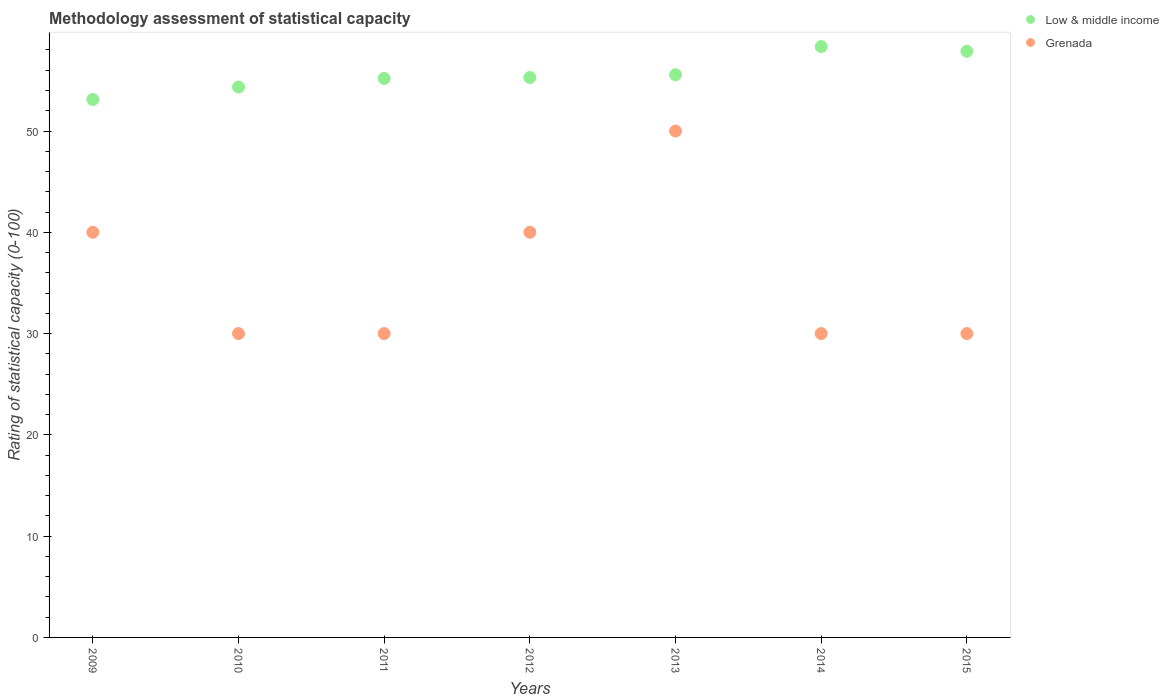How many different coloured dotlines are there?
Your response must be concise. 2. Is the number of dotlines equal to the number of legend labels?
Ensure brevity in your answer.  Yes. Across all years, what is the maximum rating of statistical capacity in Low & middle income?
Your answer should be very brief. 58.33. Across all years, what is the minimum rating of statistical capacity in Grenada?
Your answer should be very brief. 30. In which year was the rating of statistical capacity in Low & middle income maximum?
Ensure brevity in your answer.  2014. In which year was the rating of statistical capacity in Grenada minimum?
Give a very brief answer. 2010. What is the total rating of statistical capacity in Low & middle income in the graph?
Ensure brevity in your answer.  389.68. What is the difference between the rating of statistical capacity in Low & middle income in 2012 and that in 2015?
Offer a terse response. -2.59. What is the difference between the rating of statistical capacity in Low & middle income in 2011 and the rating of statistical capacity in Grenada in 2009?
Your response must be concise. 15.19. What is the average rating of statistical capacity in Low & middle income per year?
Keep it short and to the point. 55.67. In the year 2009, what is the difference between the rating of statistical capacity in Grenada and rating of statistical capacity in Low & middle income?
Your response must be concise. -13.11. What is the ratio of the rating of statistical capacity in Low & middle income in 2010 to that in 2012?
Provide a short and direct response. 0.98. Is the difference between the rating of statistical capacity in Grenada in 2012 and 2013 greater than the difference between the rating of statistical capacity in Low & middle income in 2012 and 2013?
Your response must be concise. No. What is the difference between the highest and the second highest rating of statistical capacity in Low & middle income?
Offer a very short reply. 0.46. What is the difference between the highest and the lowest rating of statistical capacity in Low & middle income?
Offer a terse response. 5.22. Does the rating of statistical capacity in Low & middle income monotonically increase over the years?
Your answer should be very brief. No. Is the rating of statistical capacity in Low & middle income strictly greater than the rating of statistical capacity in Grenada over the years?
Give a very brief answer. Yes. Is the rating of statistical capacity in Grenada strictly less than the rating of statistical capacity in Low & middle income over the years?
Provide a short and direct response. Yes. Are the values on the major ticks of Y-axis written in scientific E-notation?
Your response must be concise. No. Does the graph contain any zero values?
Your answer should be very brief. No. Where does the legend appear in the graph?
Provide a succinct answer. Top right. How many legend labels are there?
Make the answer very short. 2. How are the legend labels stacked?
Give a very brief answer. Vertical. What is the title of the graph?
Offer a very short reply. Methodology assessment of statistical capacity. What is the label or title of the X-axis?
Offer a terse response. Years. What is the label or title of the Y-axis?
Keep it short and to the point. Rating of statistical capacity (0-100). What is the Rating of statistical capacity (0-100) of Low & middle income in 2009?
Your answer should be very brief. 53.11. What is the Rating of statistical capacity (0-100) in Low & middle income in 2010?
Your answer should be very brief. 54.34. What is the Rating of statistical capacity (0-100) in Grenada in 2010?
Offer a very short reply. 30. What is the Rating of statistical capacity (0-100) of Low & middle income in 2011?
Offer a terse response. 55.19. What is the Rating of statistical capacity (0-100) of Grenada in 2011?
Make the answer very short. 30. What is the Rating of statistical capacity (0-100) in Low & middle income in 2012?
Keep it short and to the point. 55.28. What is the Rating of statistical capacity (0-100) in Grenada in 2012?
Ensure brevity in your answer.  40. What is the Rating of statistical capacity (0-100) in Low & middle income in 2013?
Give a very brief answer. 55.56. What is the Rating of statistical capacity (0-100) of Low & middle income in 2014?
Provide a short and direct response. 58.33. What is the Rating of statistical capacity (0-100) of Grenada in 2014?
Your answer should be compact. 30. What is the Rating of statistical capacity (0-100) in Low & middle income in 2015?
Your answer should be compact. 57.87. Across all years, what is the maximum Rating of statistical capacity (0-100) in Low & middle income?
Make the answer very short. 58.33. Across all years, what is the minimum Rating of statistical capacity (0-100) in Low & middle income?
Ensure brevity in your answer.  53.11. What is the total Rating of statistical capacity (0-100) of Low & middle income in the graph?
Offer a very short reply. 389.68. What is the total Rating of statistical capacity (0-100) in Grenada in the graph?
Give a very brief answer. 250. What is the difference between the Rating of statistical capacity (0-100) in Low & middle income in 2009 and that in 2010?
Keep it short and to the point. -1.23. What is the difference between the Rating of statistical capacity (0-100) of Grenada in 2009 and that in 2010?
Make the answer very short. 10. What is the difference between the Rating of statistical capacity (0-100) in Low & middle income in 2009 and that in 2011?
Offer a terse response. -2.08. What is the difference between the Rating of statistical capacity (0-100) of Grenada in 2009 and that in 2011?
Offer a very short reply. 10. What is the difference between the Rating of statistical capacity (0-100) in Low & middle income in 2009 and that in 2012?
Make the answer very short. -2.17. What is the difference between the Rating of statistical capacity (0-100) in Low & middle income in 2009 and that in 2013?
Offer a terse response. -2.44. What is the difference between the Rating of statistical capacity (0-100) of Low & middle income in 2009 and that in 2014?
Give a very brief answer. -5.22. What is the difference between the Rating of statistical capacity (0-100) in Low & middle income in 2009 and that in 2015?
Your response must be concise. -4.76. What is the difference between the Rating of statistical capacity (0-100) of Low & middle income in 2010 and that in 2011?
Give a very brief answer. -0.85. What is the difference between the Rating of statistical capacity (0-100) of Low & middle income in 2010 and that in 2012?
Your answer should be very brief. -0.94. What is the difference between the Rating of statistical capacity (0-100) of Grenada in 2010 and that in 2012?
Provide a succinct answer. -10. What is the difference between the Rating of statistical capacity (0-100) in Low & middle income in 2010 and that in 2013?
Your answer should be very brief. -1.22. What is the difference between the Rating of statistical capacity (0-100) in Low & middle income in 2010 and that in 2014?
Offer a very short reply. -3.99. What is the difference between the Rating of statistical capacity (0-100) in Grenada in 2010 and that in 2014?
Give a very brief answer. 0. What is the difference between the Rating of statistical capacity (0-100) in Low & middle income in 2010 and that in 2015?
Ensure brevity in your answer.  -3.53. What is the difference between the Rating of statistical capacity (0-100) of Grenada in 2010 and that in 2015?
Make the answer very short. 0. What is the difference between the Rating of statistical capacity (0-100) in Low & middle income in 2011 and that in 2012?
Provide a short and direct response. -0.09. What is the difference between the Rating of statistical capacity (0-100) of Grenada in 2011 and that in 2012?
Give a very brief answer. -10. What is the difference between the Rating of statistical capacity (0-100) of Low & middle income in 2011 and that in 2013?
Your answer should be compact. -0.37. What is the difference between the Rating of statistical capacity (0-100) of Low & middle income in 2011 and that in 2014?
Give a very brief answer. -3.14. What is the difference between the Rating of statistical capacity (0-100) in Grenada in 2011 and that in 2014?
Keep it short and to the point. 0. What is the difference between the Rating of statistical capacity (0-100) in Low & middle income in 2011 and that in 2015?
Offer a terse response. -2.68. What is the difference between the Rating of statistical capacity (0-100) of Grenada in 2011 and that in 2015?
Your answer should be compact. 0. What is the difference between the Rating of statistical capacity (0-100) of Low & middle income in 2012 and that in 2013?
Your response must be concise. -0.27. What is the difference between the Rating of statistical capacity (0-100) in Low & middle income in 2012 and that in 2014?
Offer a very short reply. -3.05. What is the difference between the Rating of statistical capacity (0-100) of Low & middle income in 2012 and that in 2015?
Offer a very short reply. -2.59. What is the difference between the Rating of statistical capacity (0-100) in Grenada in 2012 and that in 2015?
Make the answer very short. 10. What is the difference between the Rating of statistical capacity (0-100) of Low & middle income in 2013 and that in 2014?
Offer a very short reply. -2.78. What is the difference between the Rating of statistical capacity (0-100) of Low & middle income in 2013 and that in 2015?
Provide a short and direct response. -2.31. What is the difference between the Rating of statistical capacity (0-100) of Grenada in 2013 and that in 2015?
Ensure brevity in your answer.  20. What is the difference between the Rating of statistical capacity (0-100) in Low & middle income in 2014 and that in 2015?
Your answer should be compact. 0.46. What is the difference between the Rating of statistical capacity (0-100) in Grenada in 2014 and that in 2015?
Your answer should be very brief. 0. What is the difference between the Rating of statistical capacity (0-100) of Low & middle income in 2009 and the Rating of statistical capacity (0-100) of Grenada in 2010?
Your response must be concise. 23.11. What is the difference between the Rating of statistical capacity (0-100) in Low & middle income in 2009 and the Rating of statistical capacity (0-100) in Grenada in 2011?
Provide a short and direct response. 23.11. What is the difference between the Rating of statistical capacity (0-100) of Low & middle income in 2009 and the Rating of statistical capacity (0-100) of Grenada in 2012?
Provide a short and direct response. 13.11. What is the difference between the Rating of statistical capacity (0-100) of Low & middle income in 2009 and the Rating of statistical capacity (0-100) of Grenada in 2013?
Offer a very short reply. 3.11. What is the difference between the Rating of statistical capacity (0-100) of Low & middle income in 2009 and the Rating of statistical capacity (0-100) of Grenada in 2014?
Offer a very short reply. 23.11. What is the difference between the Rating of statistical capacity (0-100) of Low & middle income in 2009 and the Rating of statistical capacity (0-100) of Grenada in 2015?
Your answer should be compact. 23.11. What is the difference between the Rating of statistical capacity (0-100) of Low & middle income in 2010 and the Rating of statistical capacity (0-100) of Grenada in 2011?
Your answer should be compact. 24.34. What is the difference between the Rating of statistical capacity (0-100) of Low & middle income in 2010 and the Rating of statistical capacity (0-100) of Grenada in 2012?
Your answer should be compact. 14.34. What is the difference between the Rating of statistical capacity (0-100) of Low & middle income in 2010 and the Rating of statistical capacity (0-100) of Grenada in 2013?
Your answer should be very brief. 4.34. What is the difference between the Rating of statistical capacity (0-100) of Low & middle income in 2010 and the Rating of statistical capacity (0-100) of Grenada in 2014?
Your answer should be compact. 24.34. What is the difference between the Rating of statistical capacity (0-100) in Low & middle income in 2010 and the Rating of statistical capacity (0-100) in Grenada in 2015?
Keep it short and to the point. 24.34. What is the difference between the Rating of statistical capacity (0-100) in Low & middle income in 2011 and the Rating of statistical capacity (0-100) in Grenada in 2012?
Make the answer very short. 15.19. What is the difference between the Rating of statistical capacity (0-100) of Low & middle income in 2011 and the Rating of statistical capacity (0-100) of Grenada in 2013?
Provide a short and direct response. 5.19. What is the difference between the Rating of statistical capacity (0-100) of Low & middle income in 2011 and the Rating of statistical capacity (0-100) of Grenada in 2014?
Provide a short and direct response. 25.19. What is the difference between the Rating of statistical capacity (0-100) of Low & middle income in 2011 and the Rating of statistical capacity (0-100) of Grenada in 2015?
Ensure brevity in your answer.  25.19. What is the difference between the Rating of statistical capacity (0-100) of Low & middle income in 2012 and the Rating of statistical capacity (0-100) of Grenada in 2013?
Give a very brief answer. 5.28. What is the difference between the Rating of statistical capacity (0-100) of Low & middle income in 2012 and the Rating of statistical capacity (0-100) of Grenada in 2014?
Your answer should be very brief. 25.28. What is the difference between the Rating of statistical capacity (0-100) in Low & middle income in 2012 and the Rating of statistical capacity (0-100) in Grenada in 2015?
Offer a very short reply. 25.28. What is the difference between the Rating of statistical capacity (0-100) in Low & middle income in 2013 and the Rating of statistical capacity (0-100) in Grenada in 2014?
Offer a terse response. 25.56. What is the difference between the Rating of statistical capacity (0-100) in Low & middle income in 2013 and the Rating of statistical capacity (0-100) in Grenada in 2015?
Give a very brief answer. 25.56. What is the difference between the Rating of statistical capacity (0-100) in Low & middle income in 2014 and the Rating of statistical capacity (0-100) in Grenada in 2015?
Give a very brief answer. 28.33. What is the average Rating of statistical capacity (0-100) in Low & middle income per year?
Your answer should be compact. 55.67. What is the average Rating of statistical capacity (0-100) of Grenada per year?
Provide a short and direct response. 35.71. In the year 2009, what is the difference between the Rating of statistical capacity (0-100) of Low & middle income and Rating of statistical capacity (0-100) of Grenada?
Offer a very short reply. 13.11. In the year 2010, what is the difference between the Rating of statistical capacity (0-100) in Low & middle income and Rating of statistical capacity (0-100) in Grenada?
Make the answer very short. 24.34. In the year 2011, what is the difference between the Rating of statistical capacity (0-100) of Low & middle income and Rating of statistical capacity (0-100) of Grenada?
Your answer should be compact. 25.19. In the year 2012, what is the difference between the Rating of statistical capacity (0-100) in Low & middle income and Rating of statistical capacity (0-100) in Grenada?
Give a very brief answer. 15.28. In the year 2013, what is the difference between the Rating of statistical capacity (0-100) in Low & middle income and Rating of statistical capacity (0-100) in Grenada?
Ensure brevity in your answer.  5.56. In the year 2014, what is the difference between the Rating of statistical capacity (0-100) in Low & middle income and Rating of statistical capacity (0-100) in Grenada?
Your answer should be very brief. 28.33. In the year 2015, what is the difference between the Rating of statistical capacity (0-100) in Low & middle income and Rating of statistical capacity (0-100) in Grenada?
Ensure brevity in your answer.  27.87. What is the ratio of the Rating of statistical capacity (0-100) of Low & middle income in 2009 to that in 2010?
Your answer should be very brief. 0.98. What is the ratio of the Rating of statistical capacity (0-100) in Low & middle income in 2009 to that in 2011?
Your answer should be compact. 0.96. What is the ratio of the Rating of statistical capacity (0-100) of Grenada in 2009 to that in 2011?
Your response must be concise. 1.33. What is the ratio of the Rating of statistical capacity (0-100) of Low & middle income in 2009 to that in 2012?
Your answer should be very brief. 0.96. What is the ratio of the Rating of statistical capacity (0-100) in Grenada in 2009 to that in 2012?
Your response must be concise. 1. What is the ratio of the Rating of statistical capacity (0-100) of Low & middle income in 2009 to that in 2013?
Provide a short and direct response. 0.96. What is the ratio of the Rating of statistical capacity (0-100) of Grenada in 2009 to that in 2013?
Ensure brevity in your answer.  0.8. What is the ratio of the Rating of statistical capacity (0-100) of Low & middle income in 2009 to that in 2014?
Provide a short and direct response. 0.91. What is the ratio of the Rating of statistical capacity (0-100) of Grenada in 2009 to that in 2014?
Provide a succinct answer. 1.33. What is the ratio of the Rating of statistical capacity (0-100) of Low & middle income in 2009 to that in 2015?
Give a very brief answer. 0.92. What is the ratio of the Rating of statistical capacity (0-100) of Grenada in 2009 to that in 2015?
Offer a very short reply. 1.33. What is the ratio of the Rating of statistical capacity (0-100) of Low & middle income in 2010 to that in 2011?
Your answer should be compact. 0.98. What is the ratio of the Rating of statistical capacity (0-100) in Grenada in 2010 to that in 2011?
Provide a succinct answer. 1. What is the ratio of the Rating of statistical capacity (0-100) in Low & middle income in 2010 to that in 2012?
Provide a short and direct response. 0.98. What is the ratio of the Rating of statistical capacity (0-100) in Grenada in 2010 to that in 2012?
Give a very brief answer. 0.75. What is the ratio of the Rating of statistical capacity (0-100) in Low & middle income in 2010 to that in 2013?
Make the answer very short. 0.98. What is the ratio of the Rating of statistical capacity (0-100) of Low & middle income in 2010 to that in 2014?
Keep it short and to the point. 0.93. What is the ratio of the Rating of statistical capacity (0-100) in Grenada in 2010 to that in 2014?
Provide a succinct answer. 1. What is the ratio of the Rating of statistical capacity (0-100) in Low & middle income in 2010 to that in 2015?
Give a very brief answer. 0.94. What is the ratio of the Rating of statistical capacity (0-100) of Grenada in 2010 to that in 2015?
Your answer should be compact. 1. What is the ratio of the Rating of statistical capacity (0-100) in Low & middle income in 2011 to that in 2014?
Offer a terse response. 0.95. What is the ratio of the Rating of statistical capacity (0-100) of Low & middle income in 2011 to that in 2015?
Offer a very short reply. 0.95. What is the ratio of the Rating of statistical capacity (0-100) in Low & middle income in 2012 to that in 2013?
Give a very brief answer. 1. What is the ratio of the Rating of statistical capacity (0-100) in Low & middle income in 2012 to that in 2014?
Offer a very short reply. 0.95. What is the ratio of the Rating of statistical capacity (0-100) of Grenada in 2012 to that in 2014?
Your answer should be compact. 1.33. What is the ratio of the Rating of statistical capacity (0-100) in Low & middle income in 2012 to that in 2015?
Your answer should be compact. 0.96. What is the ratio of the Rating of statistical capacity (0-100) of Low & middle income in 2013 to that in 2014?
Offer a very short reply. 0.95. What is the ratio of the Rating of statistical capacity (0-100) of Grenada in 2013 to that in 2014?
Make the answer very short. 1.67. What is the ratio of the Rating of statistical capacity (0-100) in Low & middle income in 2013 to that in 2015?
Your answer should be compact. 0.96. What is the difference between the highest and the second highest Rating of statistical capacity (0-100) of Low & middle income?
Your answer should be compact. 0.46. What is the difference between the highest and the lowest Rating of statistical capacity (0-100) of Low & middle income?
Give a very brief answer. 5.22. 